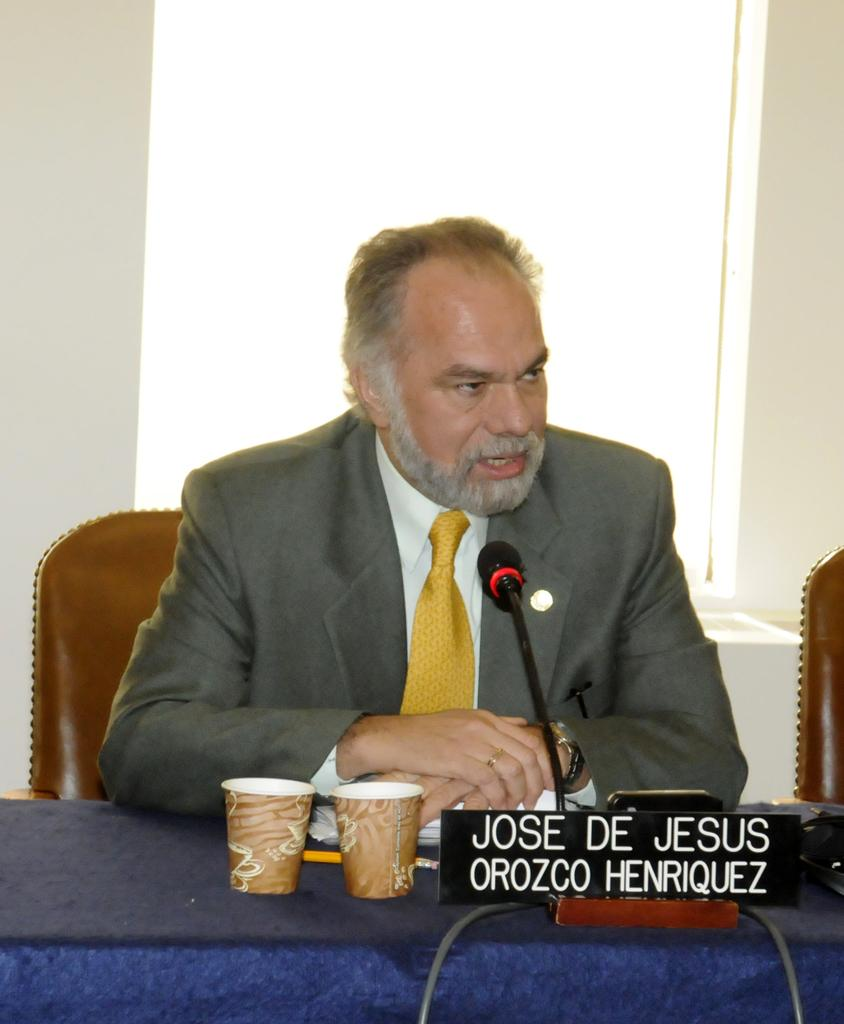What is the person in the image holding? The person is holding a guitar. What is the person doing with the guitar? The person is playing the guitar. Can you describe the location of the person in the image? The person is standing near a tree. What is the person doing while standing near the tree? The person is talking on the phone. What type of wood can be seen in the image? There is no wood present in the image. What level of difficulty is the person playing on the guitar? The image does not provide information about the level of difficulty of the guitar playing. 